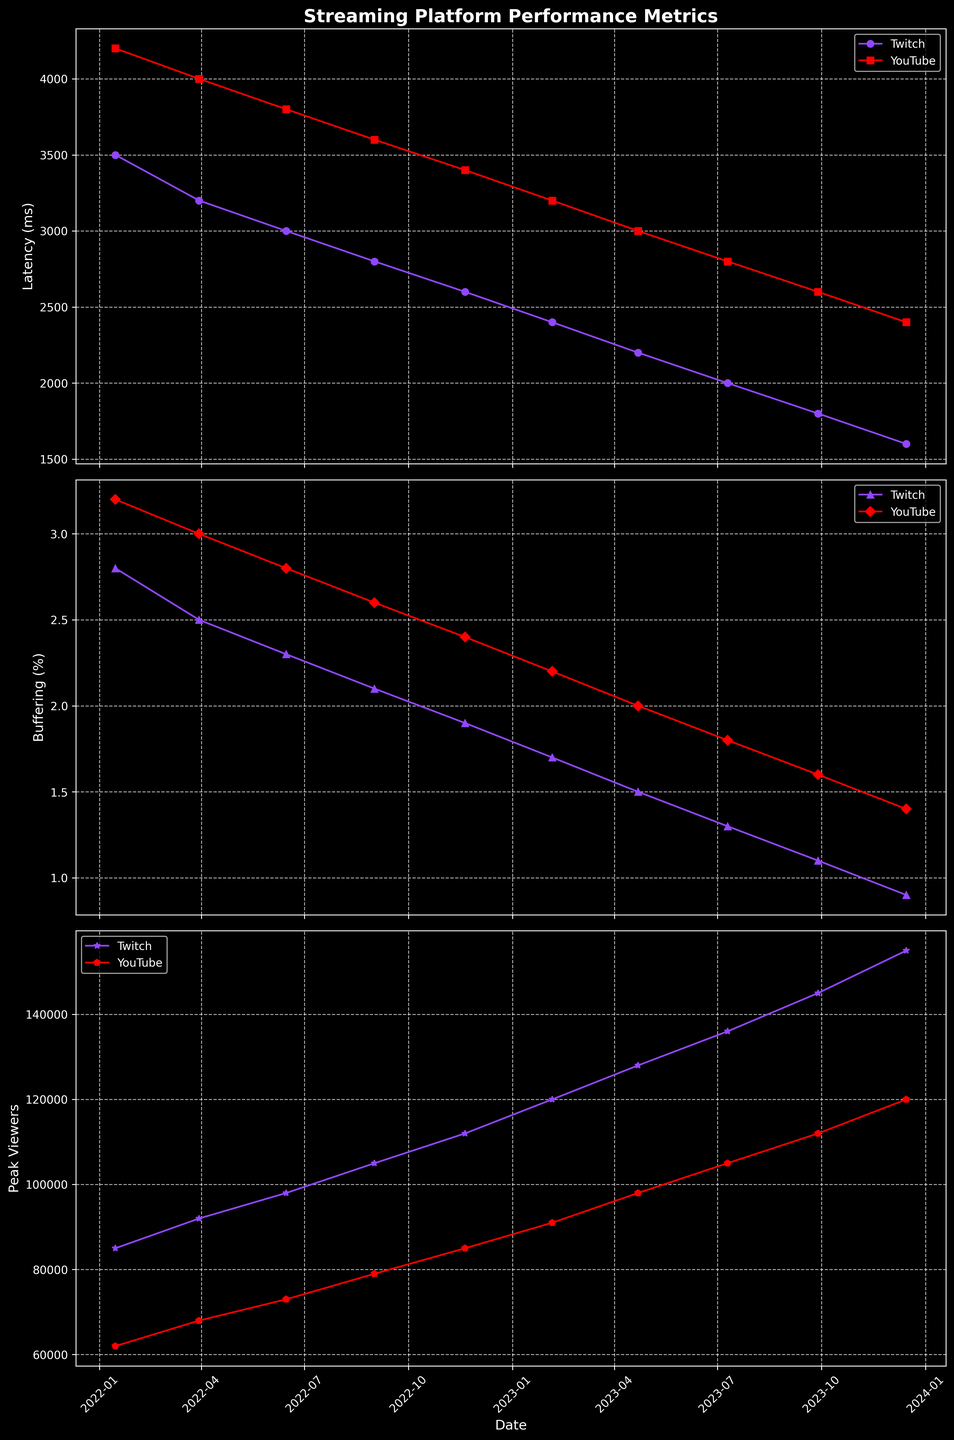Which platform had a lower buffering percentage in 2023-07-10? Twitch had a lower buffering percentage than YouTube on 2023-07-10. According to the graph, Twitch had 1.3% buffering while YouTube had 1.8%.
Answer: Twitch What is the difference in latency between Twitch and YouTube in 2022-01-15? The latency for Twitch on 2022-01-15 is 3500 ms, and for YouTube, it is 4200 ms. The difference is 4200 - 3500 = 700 ms.
Answer: 700 ms How did the peak viewers count for YouTube change from 2022-06-15 to 2023-02-05? The peak viewers for YouTube increased from 73000 on 2022-06-15 to 91000 on 2023-02-05. The change is 91000 - 73000 = 18000 viewers.
Answer: 18000 During which period did Twitch see the highest increase in peak viewers? The highest increase is observed from 2023-07-10 to 2023-09-28. The peak viewers increased from 136000 to 145000, which is an increase of 9000 viewers.
Answer: 2023-07-10 to 2023-09-28 By what percentage did YouTube's latency decrease between 2022-01-15 and 2023-12-15? YouTube's latency decreased from 4200 ms on 2022-01-15 to 2400 ms on 2023-12-15. The percentage decrease is ((4200 - 2400) / 4200) * 100 = 42.86%.
Answer: 42.86% Compare the viewer count of Twitch and YouTube on the date when Twitch had the lowest buffering percentage. The lowest buffering percentage for Twitch is 0.9% on 2023-12-15. On this date, Twitch had 155000 peak viewers and YouTube had 120000 peak viewers.
Answer: Twitch had 35000 more viewers On which date did both platforms have their lowest latency, and what was it? Both platforms had their lowest latency on 2023-12-15. The latencies were 1600 ms for Twitch and 2400 ms for YouTube.
Answer: 2023-12-15 Calculate the average peak viewer count for Twitch throughout the data provided. Sum of Twitch peak viewers = 85000 + 92000 + 98000 + 105000 + 112000 + 120000 + 128000 + 136000 + 145000 + 155000 = 1095000. Number of observations = 10. The average is 1095000 / 10 = 109500 viewers.
Answer: 109500 viewers 